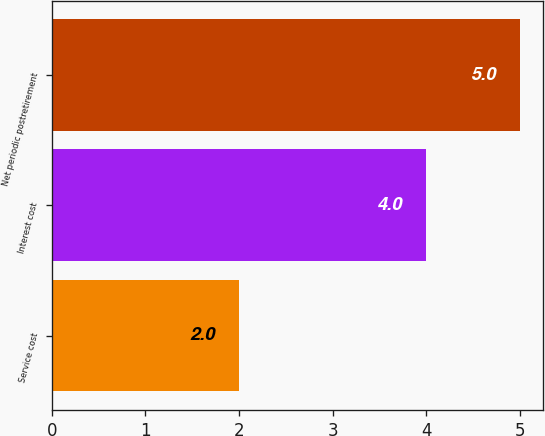Convert chart. <chart><loc_0><loc_0><loc_500><loc_500><bar_chart><fcel>Service cost<fcel>Interest cost<fcel>Net periodic postretirement<nl><fcel>2<fcel>4<fcel>5<nl></chart> 